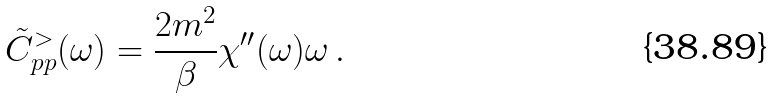Convert formula to latex. <formula><loc_0><loc_0><loc_500><loc_500>\tilde { C } _ { p p } ^ { > } ( \omega ) = \frac { 2 m ^ { 2 } } { \beta } \chi ^ { \prime \prime } ( \omega ) \omega \, .</formula> 